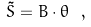<formula> <loc_0><loc_0><loc_500><loc_500>\tilde { S } = B \cdot \theta \ ,</formula> 